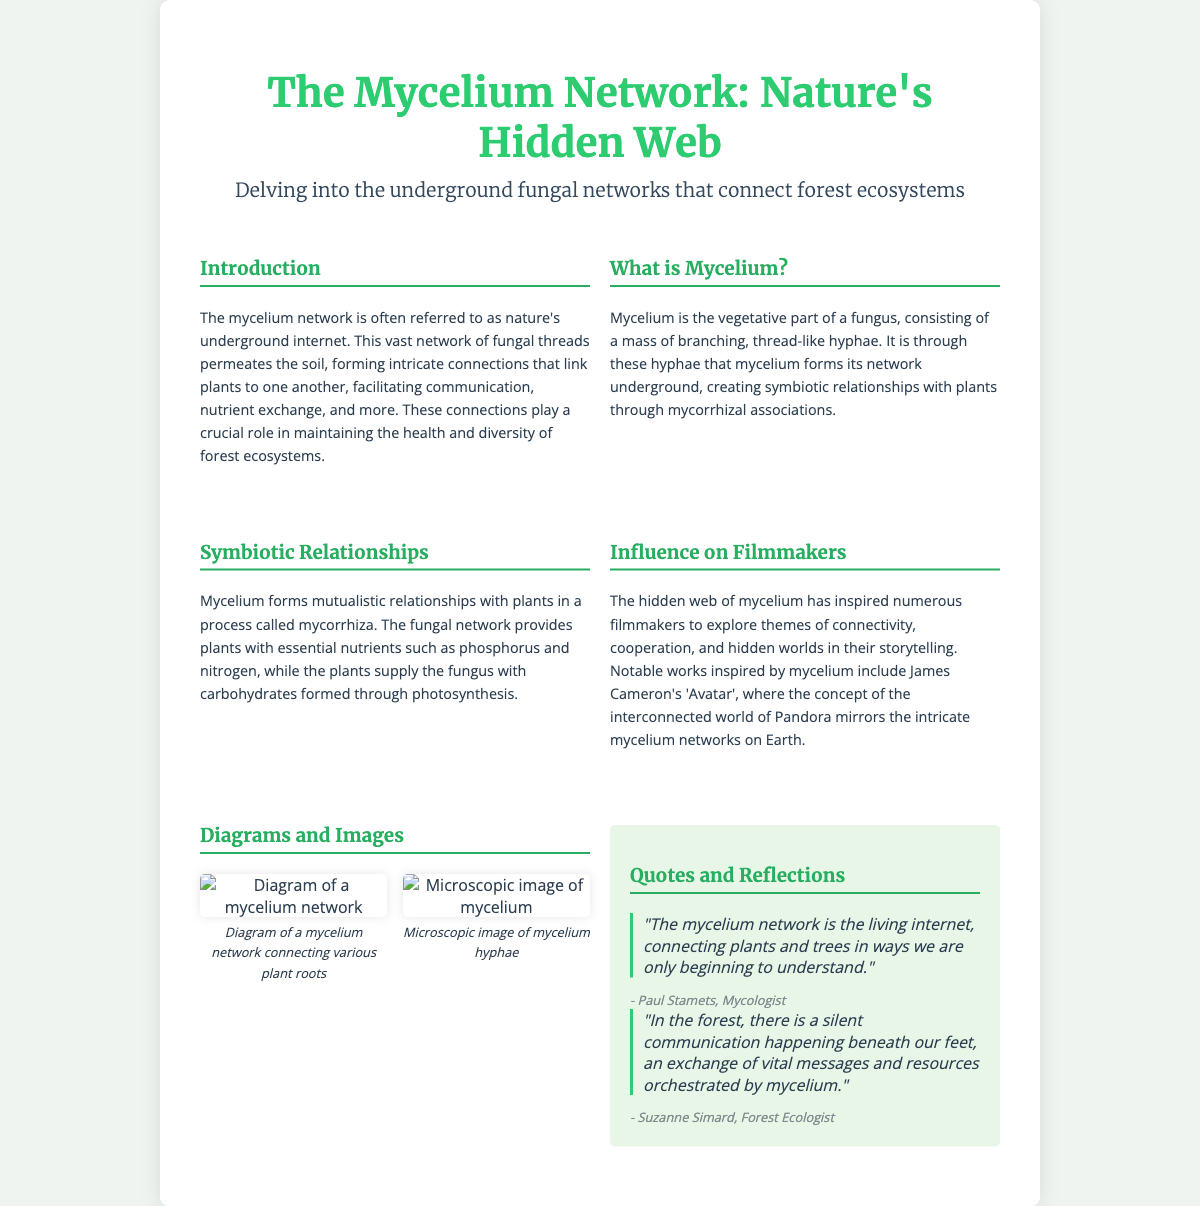What is the title of the poster? The title of the poster is featured prominently at the top of the document.
Answer: The Mycelium Network: Nature's Hidden Web What is mycelium described as in the introduction? The introduction refers to mycelium as nature's underground internet, highlighting its role in connecting ecosystems.
Answer: Nature's underground internet What are the two essential nutrients provided by mycelium to plants? The text highlights phosphorus and nitrogen as the essential nutrients supplied by mycelium to plants.
Answer: Phosphorus and nitrogen Who is quoted regarding the mycelium network in the document? The document features quotes from notable individuals with expertise in mycology and ecology.
Answer: Paul Stamets and Suzanne Simard What notable film is mentioned as being inspired by mycelium? The influence of mycelium on filmmaking is illustrated through a well-known film that explores interconnected worlds.
Answer: Avatar What does the mycelium network facilitate between plants? The document discusses the mycelium network’s role in fostering crucial interactions among the plant community.
Answer: Communication and nutrient exchange 